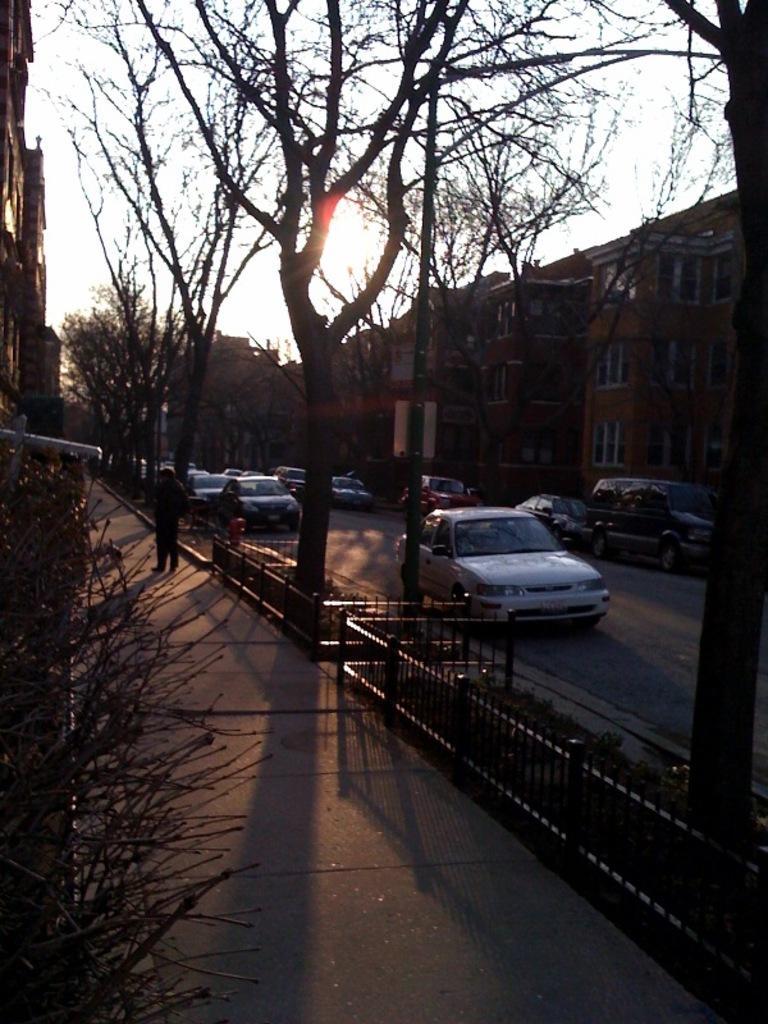Can you describe this image briefly? In the center of the image there are trees. There is a road on which there are cars. To the right side of the image there are buildings. 